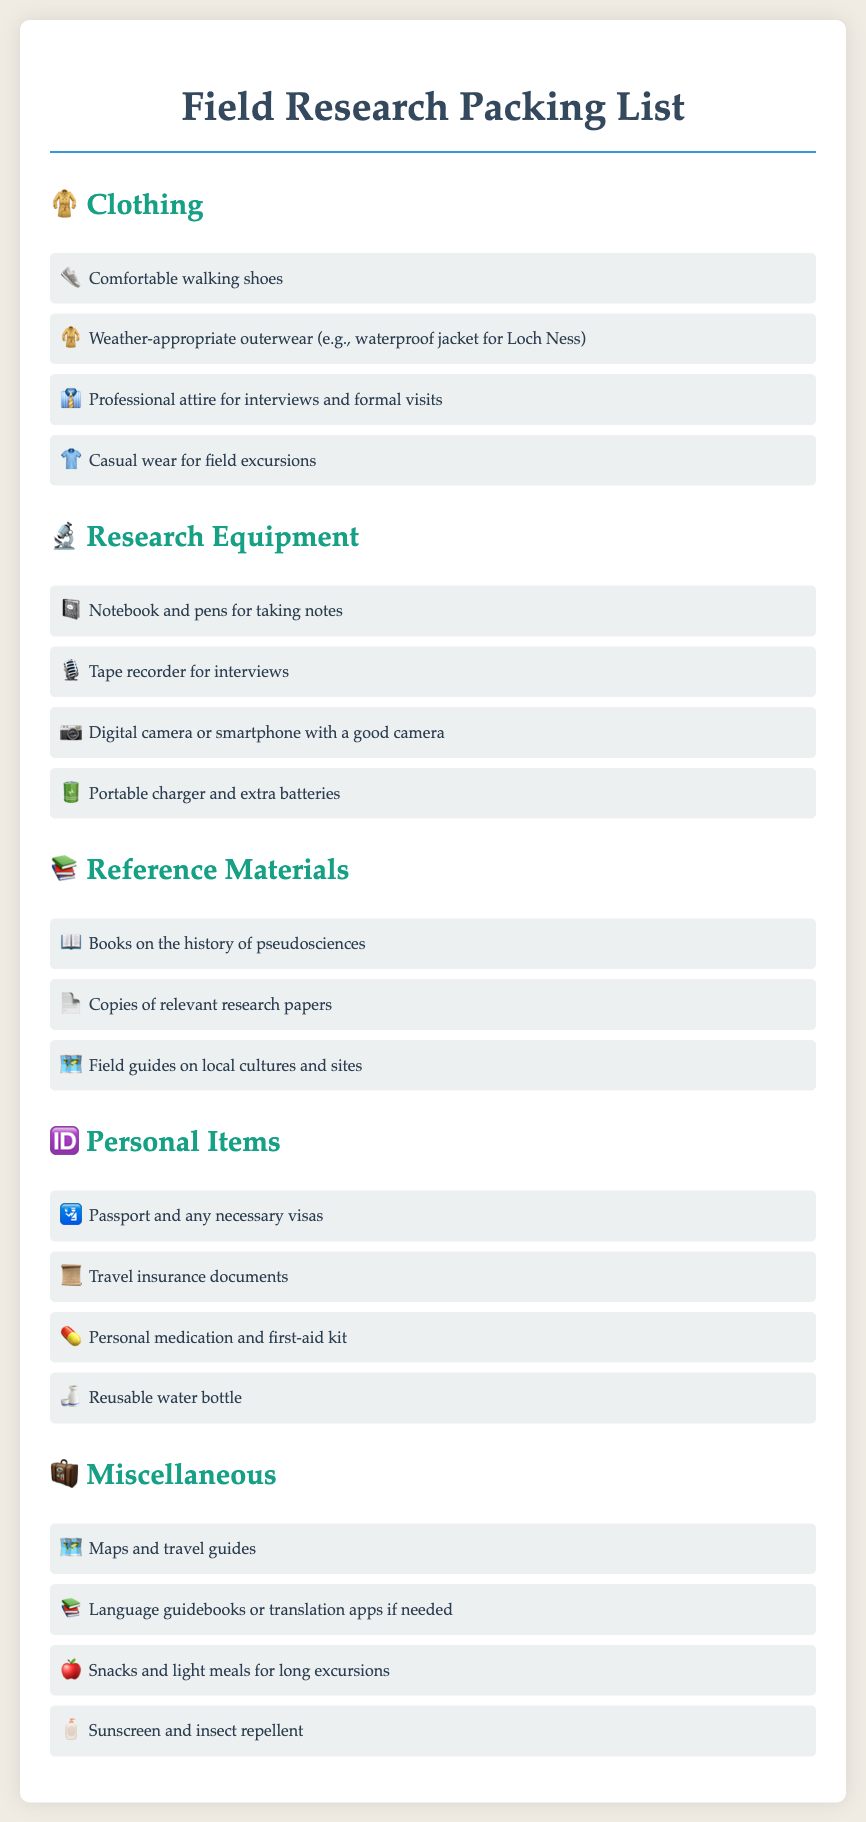What type of shoes are recommended? The packing list specifies "Comfortable walking shoes" as a recommended type of footwear.
Answer: Comfortable walking shoes What is necessary weather gear for the trip? The document mentions "weather-appropriate outerwear (e.g., waterproof jacket for Loch Ness)" as necessary gear for the trip.
Answer: Waterproof jacket for Loch Ness What item is listed for taking notes? The packing list includes a "Notebook and pens for taking notes".
Answer: Notebook and pens How many categories of items are listed in the packing list? The document divides items into five distinct categories: Clothing, Research Equipment, Reference Materials, Personal Items, and Miscellaneous.
Answer: Five What should be included for interviews? The list includes a "Tape recorder for interviews" as necessary research equipment.
Answer: Tape recorder What personal documents are required? The packing list specifies the need for a "Passport and any necessary visas".
Answer: Passport and any necessary visas What type of material should be brought for local cultures? The document suggests bringing "Field guides on local cultures and sites" as reference materials.
Answer: Field guides on local cultures and sites What should be packed for long excursions? "Snacks and light meals for long excursions" is mentioned as a necessary item in the miscellaneous section.
Answer: Snacks and light meals Is sunscreen recommended in the packing list? Yes, the document includes "Sunscreen and insect repellent" in the miscellaneous category, indicating its recommendation.
Answer: Sunscreen and insect repellent 